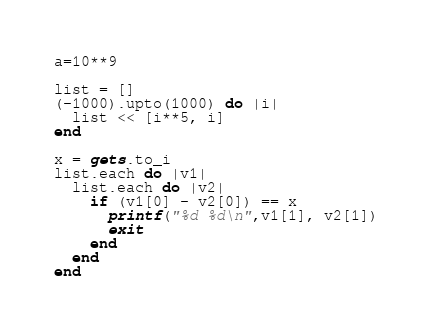Convert code to text. <code><loc_0><loc_0><loc_500><loc_500><_Ruby_>a=10**9

list = []
(-1000).upto(1000) do |i|
  list << [i**5, i]
end

x = gets.to_i
list.each do |v1|
  list.each do |v2|
    if (v1[0] - v2[0]) == x
      printf("%d %d\n",v1[1], v2[1])
      exit
    end
  end
end

</code> 